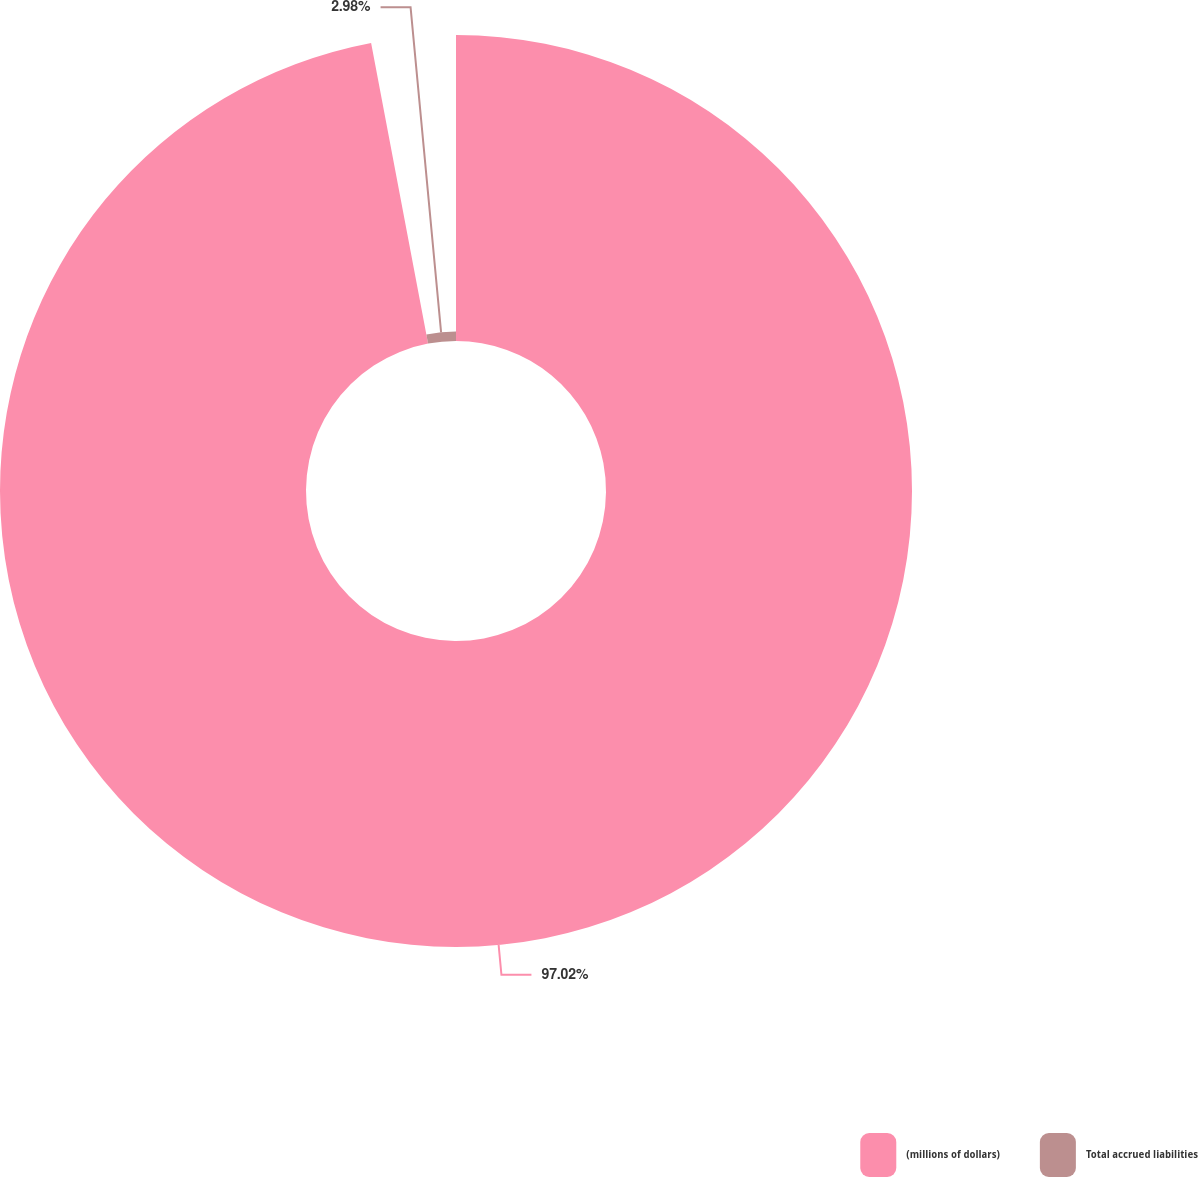Convert chart to OTSL. <chart><loc_0><loc_0><loc_500><loc_500><pie_chart><fcel>(millions of dollars)<fcel>Total accrued liabilities<nl><fcel>97.02%<fcel>2.98%<nl></chart> 